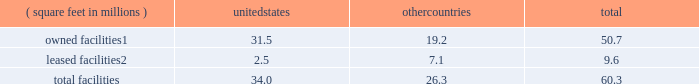There are inherent limitations on the effectiveness of our controls .
We do not expect that our disclosure controls or our internal control over financial reporting will prevent or detect all errors and all fraud .
A control system , no matter how well-designed and operated , can provide only reasonable , not absolute , assurance that the control system 2019s objectives will be met .
The design of a control system must reflect the fact that resource constraints exist , and the benefits of controls must be considered relative to their costs .
Further , because of the inherent limitations in all control systems , no evaluation of controls can provide absolute assurance that misstatements due to error or fraud will not occur or that all control issues and instances of fraud , if any , have been detected .
The design of any system of controls is based in part on certain assumptions about the likelihood of future events , and there can be no assurance that any design will succeed in achieving its stated goals under all potential future conditions .
Projections of any evaluation of the effectiveness of controls to future periods are subject to risks .
Over time , controls may become inadequate due to changes in conditions or deterioration in the degree of compliance with policies or procedures .
If our controls become inadequate , we could fail to meet our financial reporting obligations , our reputation may be adversely affected , our business and operating results could be harmed , and the market price of our stock could decline .
Item 1b .
Unresolved staff comments not applicable .
Item 2 .
Properties as of december 31 , 2016 , our major facilities consisted of : ( square feet in millions ) united states countries total owned facilities1 .
31.5 19.2 50.7 leased facilities2 .
2.5 7.1 9.6 .
1 leases and municipal grants on portions of the land used for these facilities expire on varying dates through 2109 .
2 leases expire on varying dates through 2058 and generally include renewals at our option .
Our principal executive offices are located in the u.s .
And the majority of our wafer manufacturing activities in 2016 were also located in the u.s .
One of our arizona wafer fabrication facilities is currently on hold and held in a safe state , and we are reserving the building for additional capacity and future technologies .
Incremental construction and equipment installation are required to ready the facility for its intended use .
For more information on our wafer fabrication and our assembly and test facilities , see 201cmanufacturing and assembly and test 201d in part i , item 1 of this form 10-k .
We believe that the facilities described above are suitable and adequate for our present purposes and that the productive capacity in our facilities is substantially being utilized or we have plans to utilize it .
We do not identify or allocate assets by operating segment .
For information on net property , plant and equipment by country , see 201cnote 4 : operating segments and geographic information 201d in part ii , item 8 of this form 10-k .
Item 3 .
Legal proceedings for a discussion of legal proceedings , see 201cnote 20 : commitments and contingencies 201d in part ii , item 8 of this form 10-k .
Item 4 .
Mine safety disclosures not applicable. .
What is the percent of the of the owned facilities square feet to the total square feet in the united states? 
Rationale: 92.6% of the total square feet in the united states was owned facilities
Computations: (31.5 / 34.0)
Answer: 0.92647. 